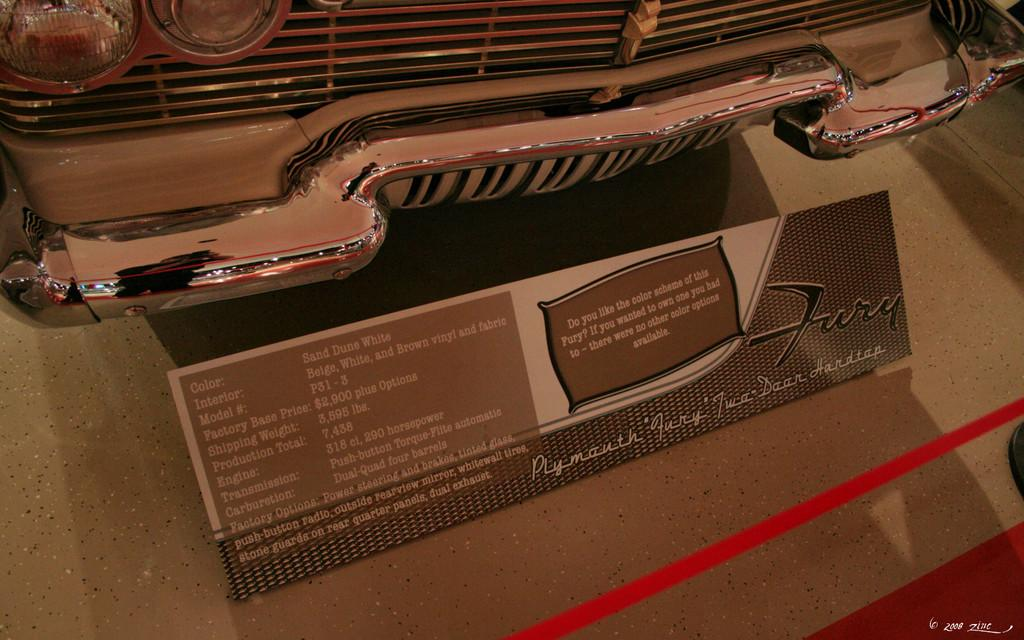What is the main subject of the image? The main subject of the image is a car. What additional information about the car can be seen in the image? There is a specification board of the car on the ground. What other object is visible in the image? There is a ribbon visible in the image. What type of verse can be seen written on the car's wing in the image? There is no wing or verse present on the car in the image. Can you describe the mountain range visible in the background of the image? There is no mountain range visible in the image; it features a car, a specification board, and a ribbon. 